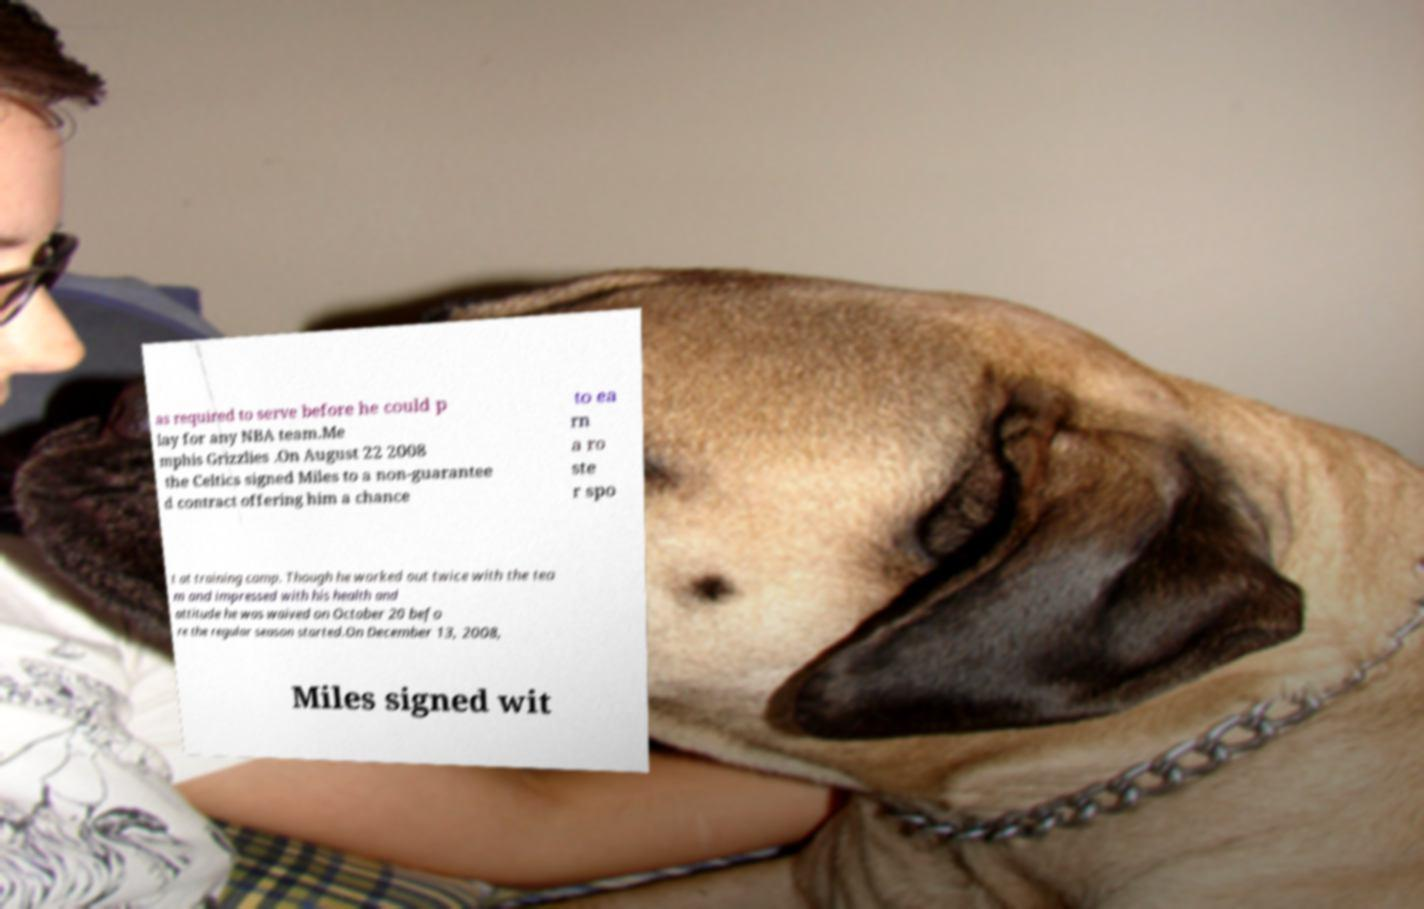There's text embedded in this image that I need extracted. Can you transcribe it verbatim? as required to serve before he could p lay for any NBA team.Me mphis Grizzlies .On August 22 2008 the Celtics signed Miles to a non-guarantee d contract offering him a chance to ea rn a ro ste r spo t at training camp. Though he worked out twice with the tea m and impressed with his health and attitude he was waived on October 20 befo re the regular season started.On December 13, 2008, Miles signed wit 